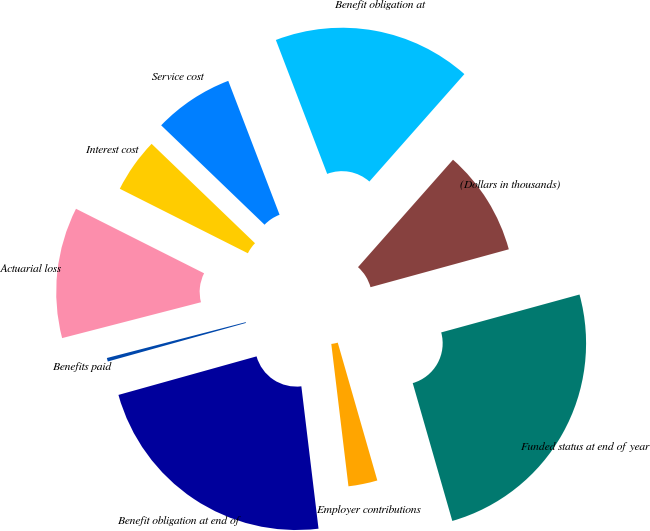Convert chart. <chart><loc_0><loc_0><loc_500><loc_500><pie_chart><fcel>(Dollars in thousands)<fcel>Benefit obligation at<fcel>Service cost<fcel>Interest cost<fcel>Actuarial loss<fcel>Benefits paid<fcel>Benefit obligation at end of<fcel>Employer contributions<fcel>Funded status at end of year<nl><fcel>9.22%<fcel>17.35%<fcel>6.99%<fcel>4.76%<fcel>11.45%<fcel>0.31%<fcel>22.58%<fcel>2.54%<fcel>24.81%<nl></chart> 